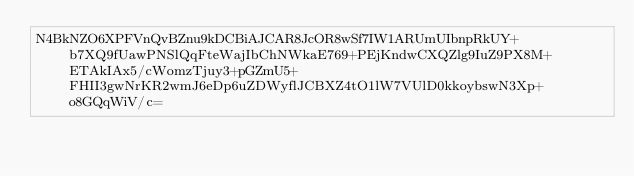Convert code to text. <code><loc_0><loc_0><loc_500><loc_500><_SML_>N4BkNZO6XPFVnQvBZnu9kDCBiAJCAR8JcOR8wSf7IW1ARUmUIbnpRkUY+b7XQ9fUawPNSlQqFteWajIbChNWkaE769+PEjKndwCXQZlg9IuZ9PX8M+ETAkIAx5/cWomzTjuy3+pGZmU5+FHII3gwNrKR2wmJ6eDp6uZDWyflJCBXZ4tO1lW7VUlD0kkoybswN3Xp+o8GQqWiV/c=</code> 